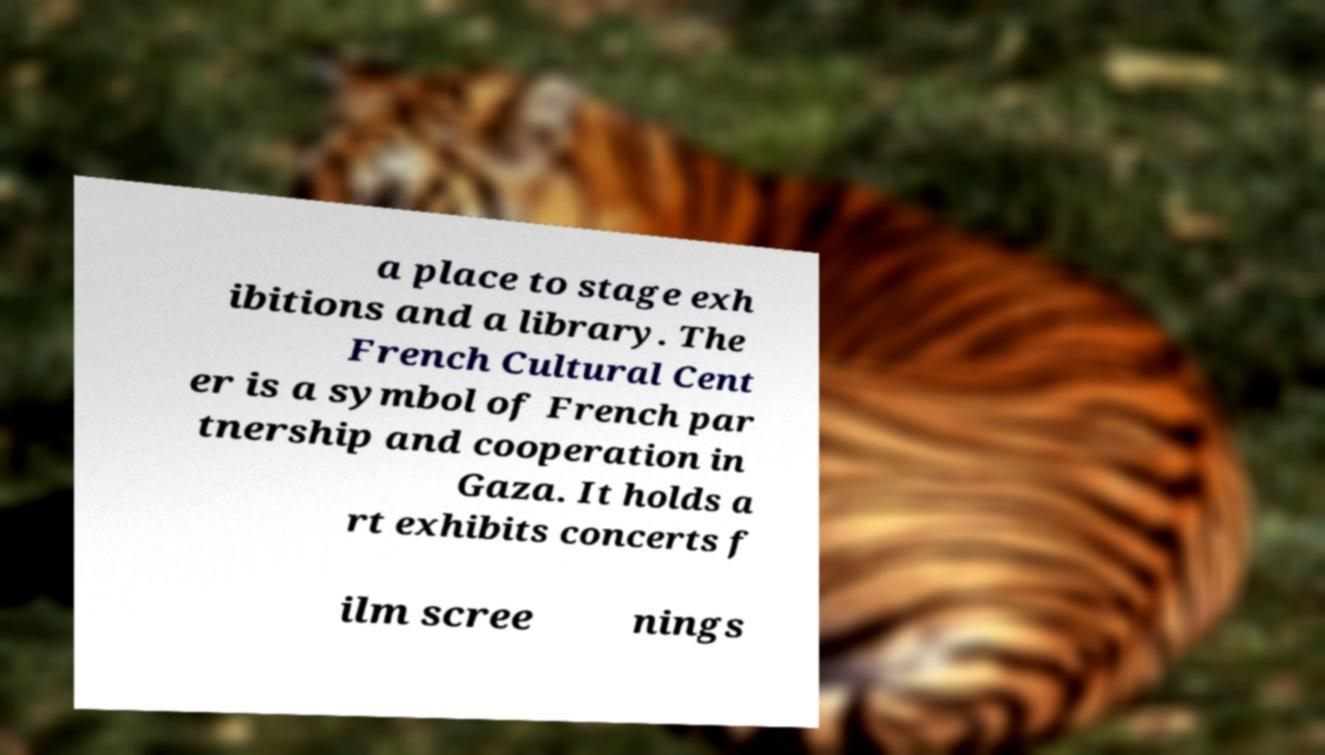There's text embedded in this image that I need extracted. Can you transcribe it verbatim? a place to stage exh ibitions and a library. The French Cultural Cent er is a symbol of French par tnership and cooperation in Gaza. It holds a rt exhibits concerts f ilm scree nings 